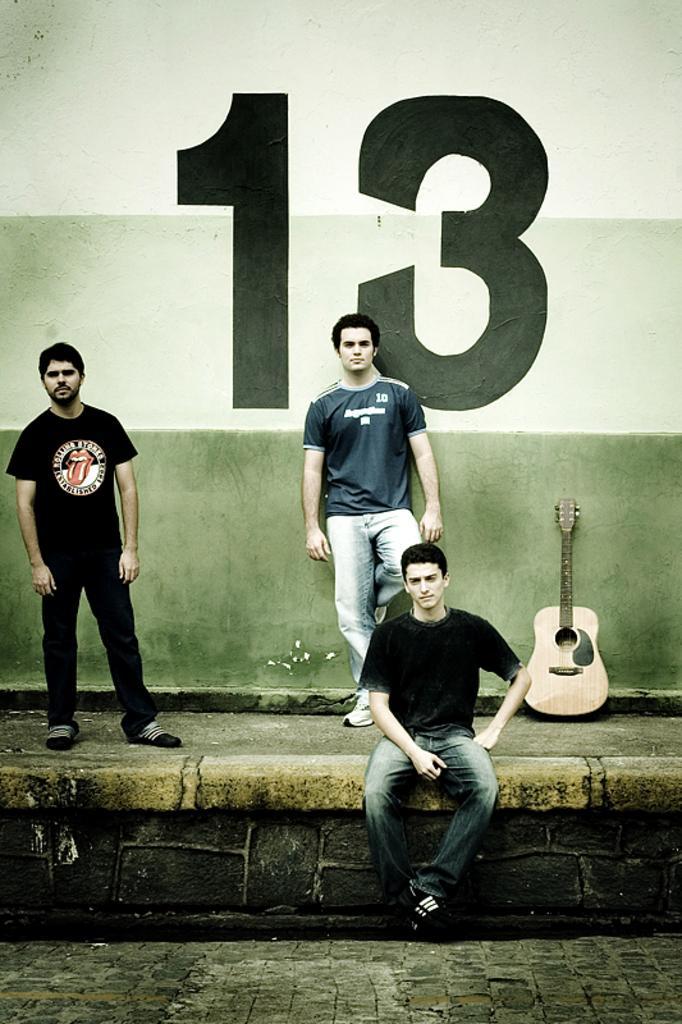How would you summarize this image in a sentence or two? There is a person in black color t-shirt, sitting. In the background, there are two persons standing, there is a wall painted with number thirteen and a guitar on the floor. 